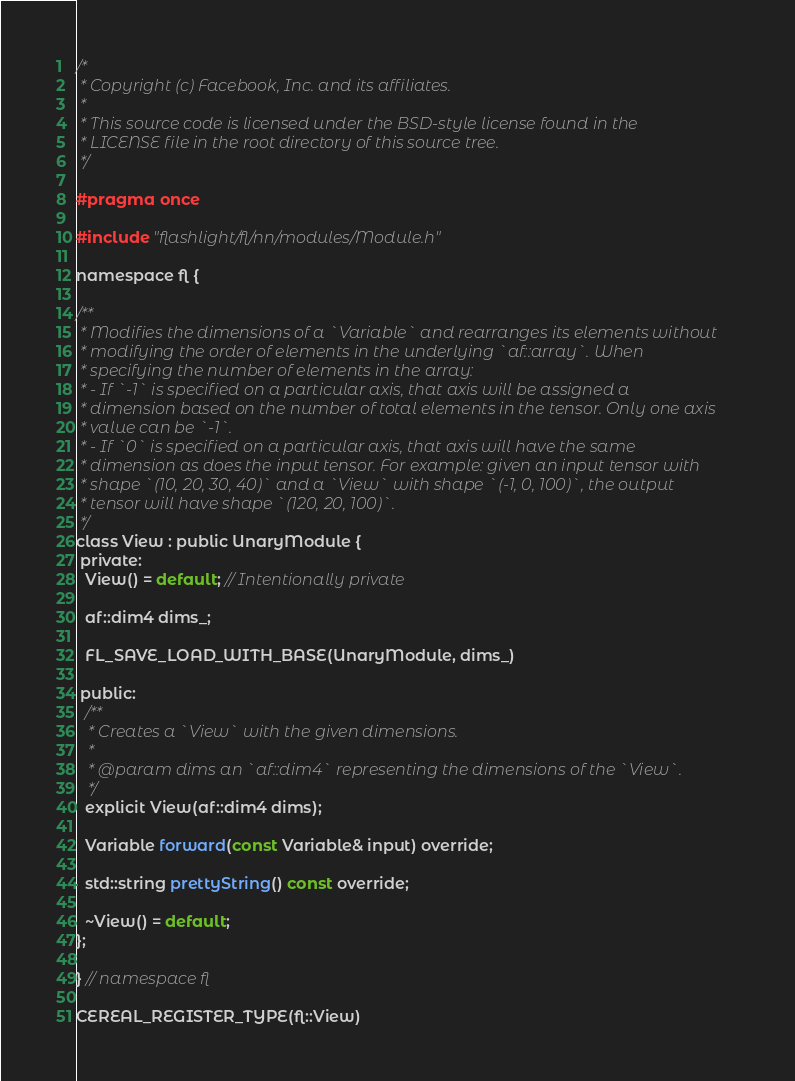<code> <loc_0><loc_0><loc_500><loc_500><_C_>/*
 * Copyright (c) Facebook, Inc. and its affiliates.
 *
 * This source code is licensed under the BSD-style license found in the
 * LICENSE file in the root directory of this source tree.
 */

#pragma once

#include "flashlight/fl/nn/modules/Module.h"

namespace fl {

/**
 * Modifies the dimensions of a `Variable` and rearranges its elements without
 * modifying the order of elements in the underlying `af::array`. When
 * specifying the number of elements in the array:
 * - If `-1` is specified on a particular axis, that axis will be assigned a
 * dimension based on the number of total elements in the tensor. Only one axis
 * value can be `-1`.
 * - If `0` is specified on a particular axis, that axis will have the same
 * dimension as does the input tensor. For example: given an input tensor with
 * shape `(10, 20, 30, 40)` and a `View` with shape `(-1, 0, 100)`, the output
 * tensor will have shape `(120, 20, 100)`.
 */
class View : public UnaryModule {
 private:
  View() = default; // Intentionally private

  af::dim4 dims_;

  FL_SAVE_LOAD_WITH_BASE(UnaryModule, dims_)

 public:
  /**
   * Creates a `View` with the given dimensions.
   *
   * @param dims an `af::dim4` representing the dimensions of the `View`.
   */
  explicit View(af::dim4 dims);

  Variable forward(const Variable& input) override;

  std::string prettyString() const override;

  ~View() = default;
};

} // namespace fl

CEREAL_REGISTER_TYPE(fl::View)
</code> 